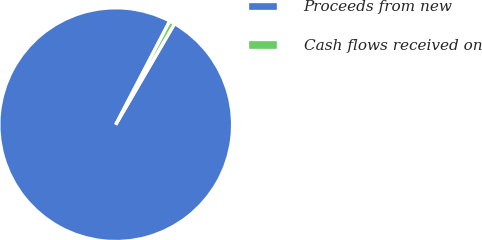Convert chart to OTSL. <chart><loc_0><loc_0><loc_500><loc_500><pie_chart><fcel>Proceeds from new<fcel>Cash flows received on<nl><fcel>99.26%<fcel>0.74%<nl></chart> 